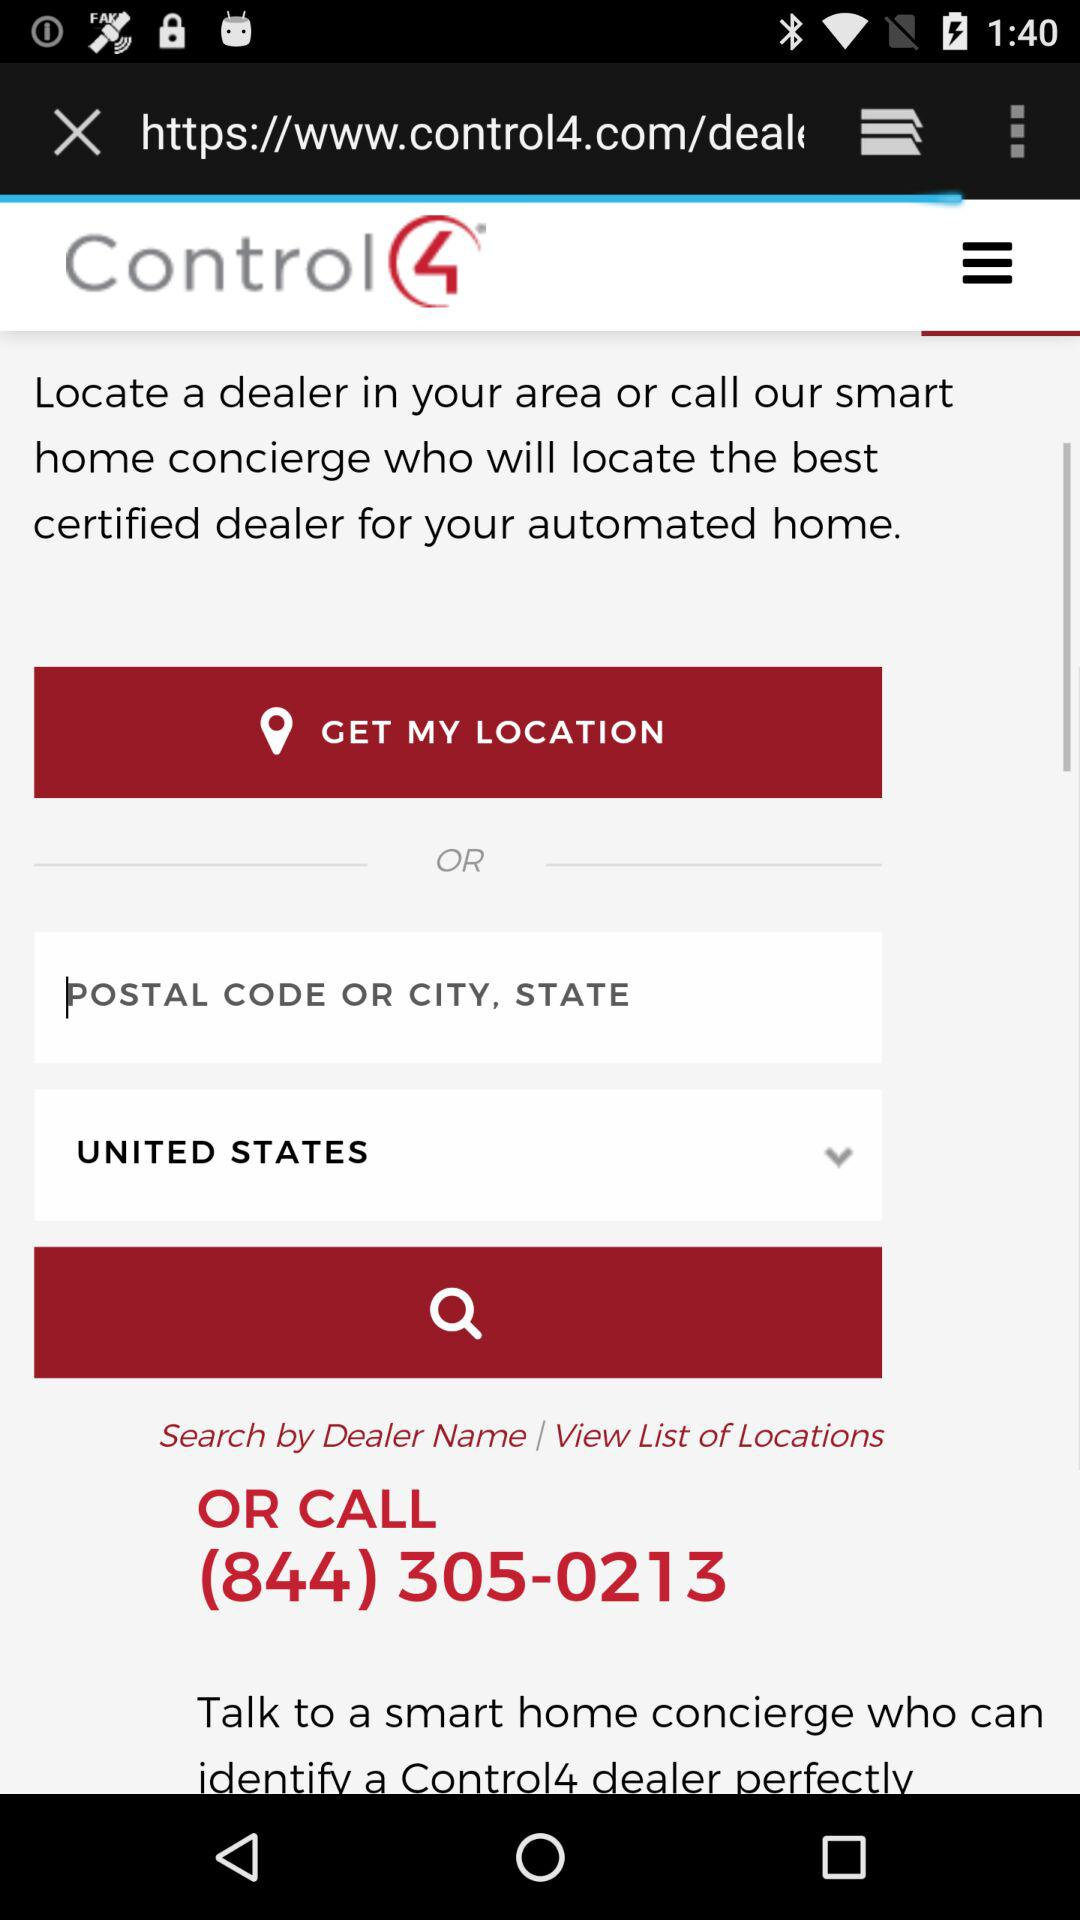Which is the selected country? The selected country is the United States. 